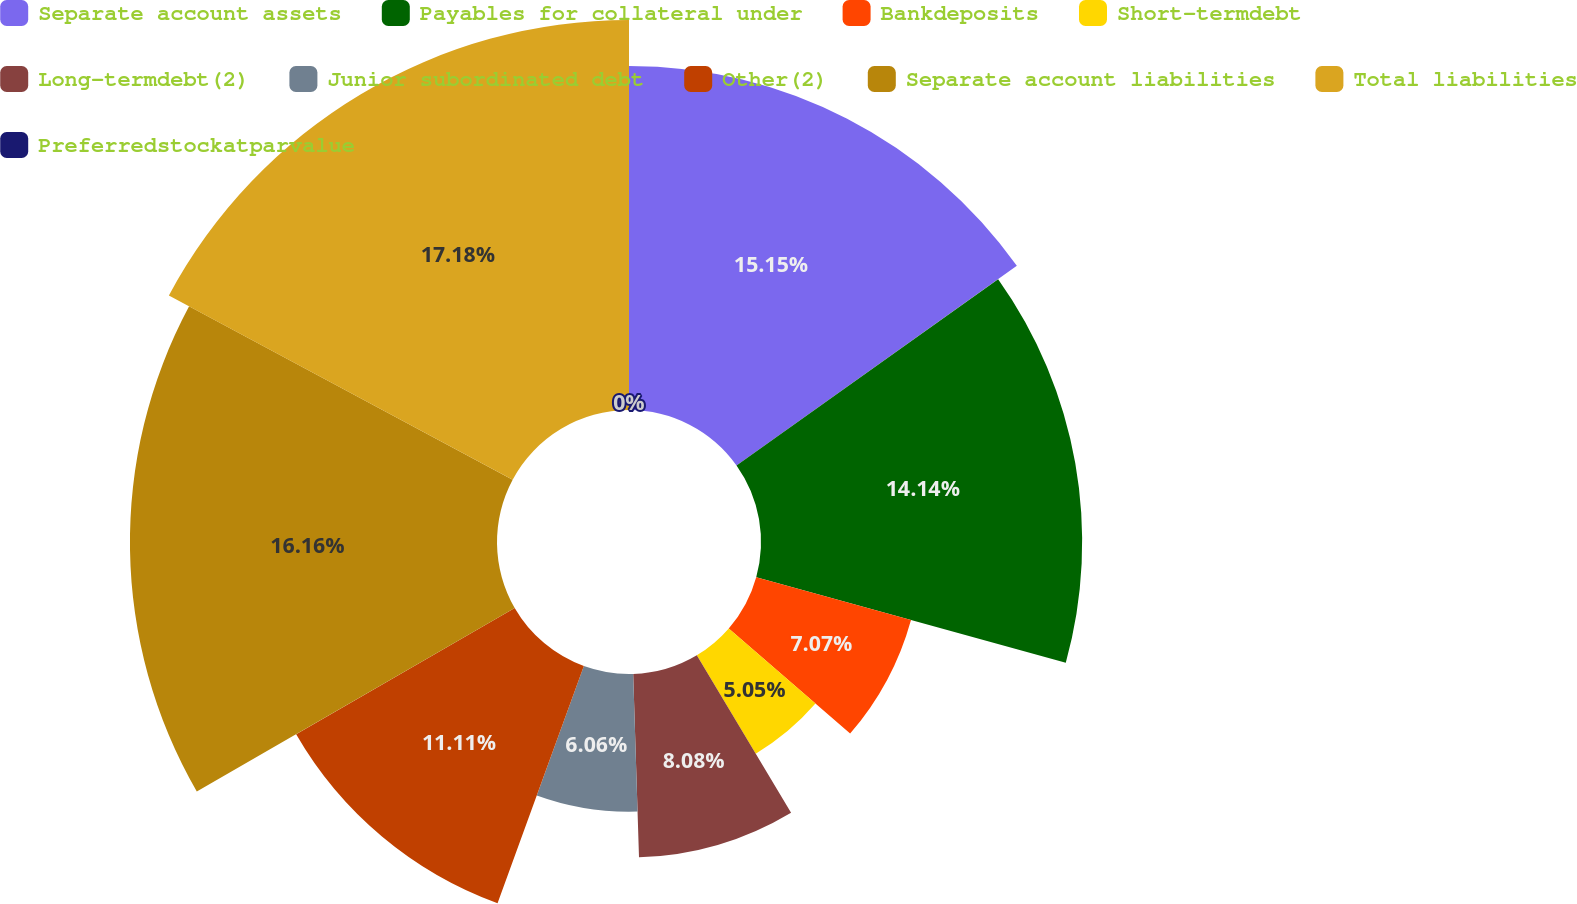Convert chart. <chart><loc_0><loc_0><loc_500><loc_500><pie_chart><fcel>Separate account assets<fcel>Payables for collateral under<fcel>Bankdeposits<fcel>Short-termdebt<fcel>Long-termdebt(2)<fcel>Junior subordinated debt<fcel>Other(2)<fcel>Separate account liabilities<fcel>Total liabilities<fcel>Preferredstockatparvalue<nl><fcel>15.15%<fcel>14.14%<fcel>7.07%<fcel>5.05%<fcel>8.08%<fcel>6.06%<fcel>11.11%<fcel>16.16%<fcel>17.17%<fcel>0.0%<nl></chart> 